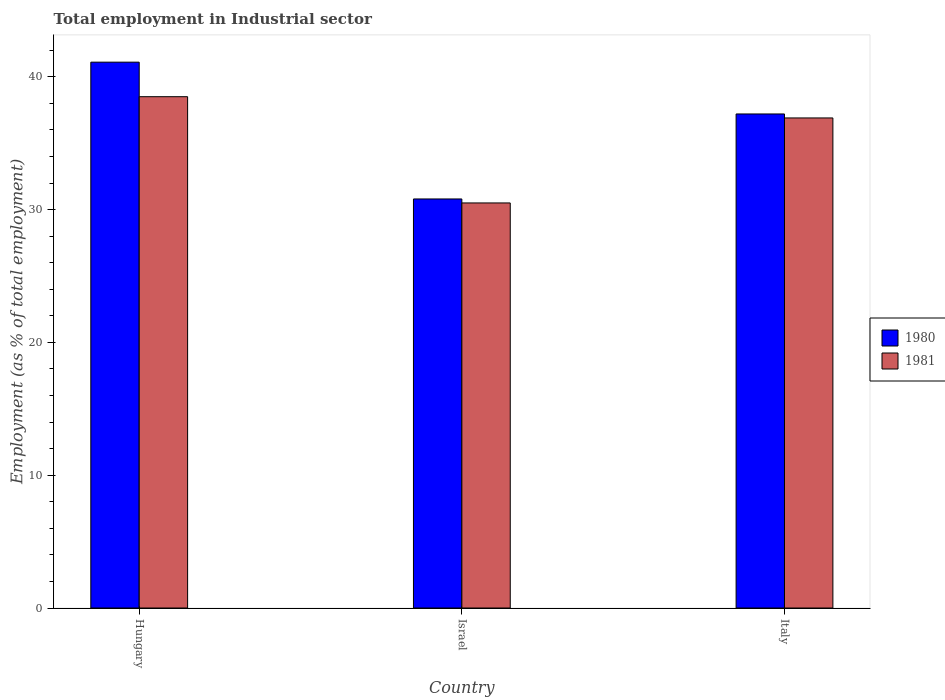How many different coloured bars are there?
Your answer should be very brief. 2. How many groups of bars are there?
Offer a very short reply. 3. Are the number of bars per tick equal to the number of legend labels?
Ensure brevity in your answer.  Yes. Are the number of bars on each tick of the X-axis equal?
Offer a terse response. Yes. How many bars are there on the 1st tick from the left?
Offer a very short reply. 2. How many bars are there on the 2nd tick from the right?
Your answer should be very brief. 2. What is the label of the 1st group of bars from the left?
Offer a very short reply. Hungary. What is the employment in industrial sector in 1981 in Hungary?
Make the answer very short. 38.5. Across all countries, what is the maximum employment in industrial sector in 1981?
Give a very brief answer. 38.5. Across all countries, what is the minimum employment in industrial sector in 1981?
Provide a short and direct response. 30.5. In which country was the employment in industrial sector in 1981 maximum?
Provide a succinct answer. Hungary. In which country was the employment in industrial sector in 1980 minimum?
Provide a succinct answer. Israel. What is the total employment in industrial sector in 1981 in the graph?
Keep it short and to the point. 105.9. What is the difference between the employment in industrial sector in 1980 in Hungary and that in Israel?
Keep it short and to the point. 10.3. What is the difference between the employment in industrial sector in 1981 in Hungary and the employment in industrial sector in 1980 in Italy?
Your response must be concise. 1.3. What is the average employment in industrial sector in 1981 per country?
Your answer should be very brief. 35.3. What is the difference between the employment in industrial sector of/in 1981 and employment in industrial sector of/in 1980 in Hungary?
Your response must be concise. -2.6. What is the ratio of the employment in industrial sector in 1981 in Israel to that in Italy?
Your response must be concise. 0.83. What is the difference between the highest and the second highest employment in industrial sector in 1981?
Offer a terse response. -1.6. What is the difference between the highest and the lowest employment in industrial sector in 1980?
Make the answer very short. 10.3. In how many countries, is the employment in industrial sector in 1980 greater than the average employment in industrial sector in 1980 taken over all countries?
Ensure brevity in your answer.  2. What does the 1st bar from the left in Italy represents?
Your answer should be compact. 1980. What does the 1st bar from the right in Israel represents?
Offer a very short reply. 1981. Are all the bars in the graph horizontal?
Your response must be concise. No. Does the graph contain grids?
Ensure brevity in your answer.  No. How are the legend labels stacked?
Provide a succinct answer. Vertical. What is the title of the graph?
Your answer should be very brief. Total employment in Industrial sector. What is the label or title of the Y-axis?
Offer a terse response. Employment (as % of total employment). What is the Employment (as % of total employment) in 1980 in Hungary?
Offer a terse response. 41.1. What is the Employment (as % of total employment) in 1981 in Hungary?
Your answer should be compact. 38.5. What is the Employment (as % of total employment) in 1980 in Israel?
Provide a succinct answer. 30.8. What is the Employment (as % of total employment) in 1981 in Israel?
Provide a short and direct response. 30.5. What is the Employment (as % of total employment) in 1980 in Italy?
Ensure brevity in your answer.  37.2. What is the Employment (as % of total employment) of 1981 in Italy?
Make the answer very short. 36.9. Across all countries, what is the maximum Employment (as % of total employment) in 1980?
Your response must be concise. 41.1. Across all countries, what is the maximum Employment (as % of total employment) in 1981?
Your response must be concise. 38.5. Across all countries, what is the minimum Employment (as % of total employment) of 1980?
Offer a terse response. 30.8. Across all countries, what is the minimum Employment (as % of total employment) in 1981?
Offer a very short reply. 30.5. What is the total Employment (as % of total employment) in 1980 in the graph?
Provide a succinct answer. 109.1. What is the total Employment (as % of total employment) of 1981 in the graph?
Make the answer very short. 105.9. What is the difference between the Employment (as % of total employment) in 1980 in Hungary and that in Israel?
Your response must be concise. 10.3. What is the difference between the Employment (as % of total employment) in 1981 in Hungary and that in Israel?
Give a very brief answer. 8. What is the difference between the Employment (as % of total employment) of 1980 in Hungary and that in Italy?
Make the answer very short. 3.9. What is the difference between the Employment (as % of total employment) in 1981 in Hungary and that in Italy?
Give a very brief answer. 1.6. What is the difference between the Employment (as % of total employment) of 1980 in Israel and that in Italy?
Provide a succinct answer. -6.4. What is the difference between the Employment (as % of total employment) of 1980 in Hungary and the Employment (as % of total employment) of 1981 in Israel?
Your answer should be very brief. 10.6. What is the difference between the Employment (as % of total employment) of 1980 in Israel and the Employment (as % of total employment) of 1981 in Italy?
Make the answer very short. -6.1. What is the average Employment (as % of total employment) in 1980 per country?
Your answer should be compact. 36.37. What is the average Employment (as % of total employment) in 1981 per country?
Your answer should be very brief. 35.3. What is the difference between the Employment (as % of total employment) in 1980 and Employment (as % of total employment) in 1981 in Israel?
Make the answer very short. 0.3. What is the ratio of the Employment (as % of total employment) of 1980 in Hungary to that in Israel?
Keep it short and to the point. 1.33. What is the ratio of the Employment (as % of total employment) of 1981 in Hungary to that in Israel?
Provide a short and direct response. 1.26. What is the ratio of the Employment (as % of total employment) of 1980 in Hungary to that in Italy?
Give a very brief answer. 1.1. What is the ratio of the Employment (as % of total employment) in 1981 in Hungary to that in Italy?
Offer a terse response. 1.04. What is the ratio of the Employment (as % of total employment) in 1980 in Israel to that in Italy?
Provide a succinct answer. 0.83. What is the ratio of the Employment (as % of total employment) of 1981 in Israel to that in Italy?
Give a very brief answer. 0.83. What is the difference between the highest and the lowest Employment (as % of total employment) of 1980?
Your response must be concise. 10.3. What is the difference between the highest and the lowest Employment (as % of total employment) in 1981?
Your response must be concise. 8. 